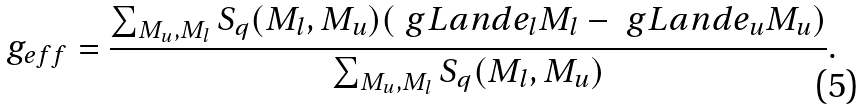<formula> <loc_0><loc_0><loc_500><loc_500>g _ { e f f } = \frac { \sum _ { M _ { u } , M _ { l } } S _ { q } ( M _ { l } , M _ { u } ) ( \ g L a n d e _ { l } M _ { l } - \ g L a n d e _ { u } M _ { u } ) } { \sum _ { M _ { u } , M _ { l } } S _ { q } ( M _ { l } , M _ { u } ) } .</formula> 